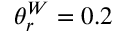<formula> <loc_0><loc_0><loc_500><loc_500>\theta _ { r } ^ { W } = 0 . 2</formula> 